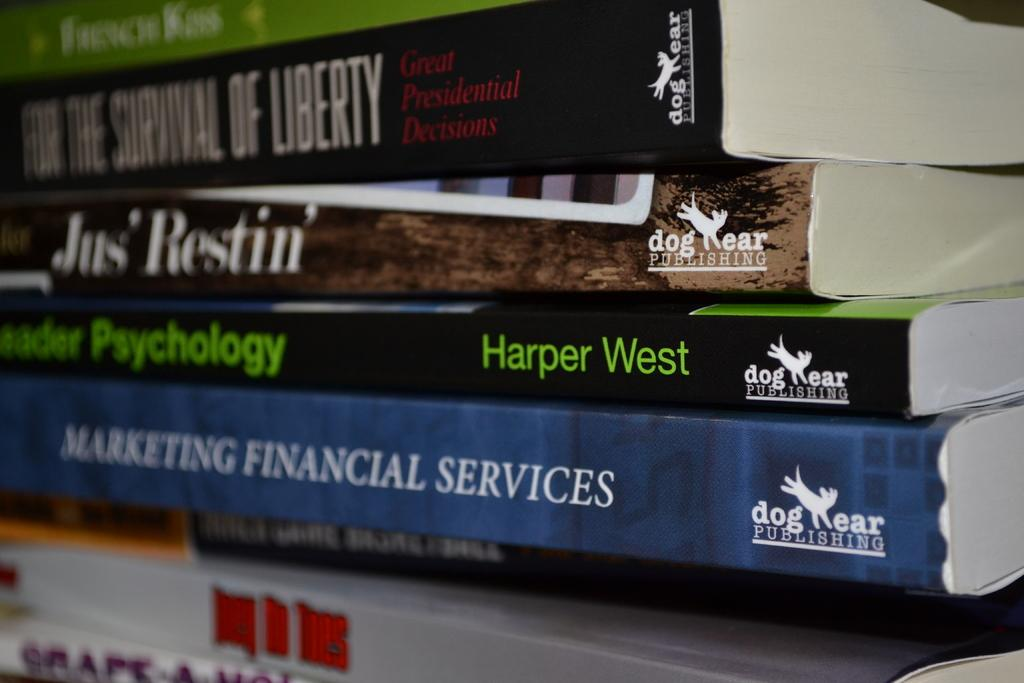<image>
Present a compact description of the photo's key features. A stack of books, the bottom one saying MArketing Financial Services. 